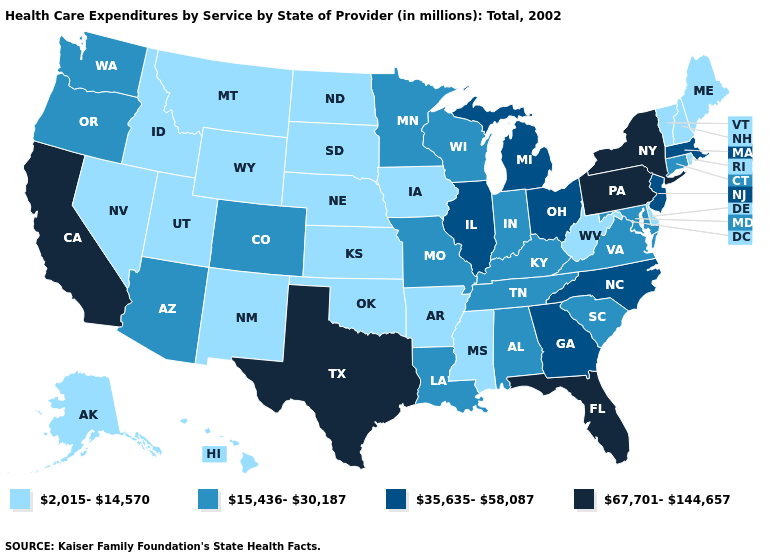What is the lowest value in the USA?
Keep it brief. 2,015-14,570. Name the states that have a value in the range 67,701-144,657?
Answer briefly. California, Florida, New York, Pennsylvania, Texas. Among the states that border Colorado , does Arizona have the lowest value?
Short answer required. No. How many symbols are there in the legend?
Be succinct. 4. What is the value of North Carolina?
Answer briefly. 35,635-58,087. What is the value of Louisiana?
Be succinct. 15,436-30,187. Which states have the lowest value in the USA?
Short answer required. Alaska, Arkansas, Delaware, Hawaii, Idaho, Iowa, Kansas, Maine, Mississippi, Montana, Nebraska, Nevada, New Hampshire, New Mexico, North Dakota, Oklahoma, Rhode Island, South Dakota, Utah, Vermont, West Virginia, Wyoming. Name the states that have a value in the range 15,436-30,187?
Answer briefly. Alabama, Arizona, Colorado, Connecticut, Indiana, Kentucky, Louisiana, Maryland, Minnesota, Missouri, Oregon, South Carolina, Tennessee, Virginia, Washington, Wisconsin. What is the highest value in states that border Idaho?
Answer briefly. 15,436-30,187. Which states hav the highest value in the South?
Keep it brief. Florida, Texas. What is the value of Minnesota?
Keep it brief. 15,436-30,187. Name the states that have a value in the range 15,436-30,187?
Write a very short answer. Alabama, Arizona, Colorado, Connecticut, Indiana, Kentucky, Louisiana, Maryland, Minnesota, Missouri, Oregon, South Carolina, Tennessee, Virginia, Washington, Wisconsin. Which states hav the highest value in the Northeast?
Concise answer only. New York, Pennsylvania. Name the states that have a value in the range 67,701-144,657?
Short answer required. California, Florida, New York, Pennsylvania, Texas. Does Missouri have the same value as Maryland?
Short answer required. Yes. 